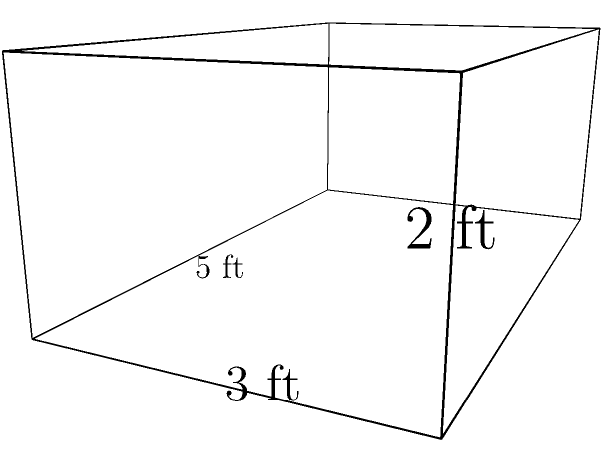A local library is organizing a book donation drive for your temperance movement organization. They've provided a rectangular storage box for the donated books. If the box measures 5 feet in length, 3 feet in width, and 2 feet in height, what is the volume of books that can be stored in this box? To find the volume of a rectangular prism (box), we need to multiply its length, width, and height.

Given:
- Length = 5 feet
- Width = 3 feet
- Height = 2 feet

Step 1: Apply the volume formula for a rectangular prism.
Volume = length × width × height

Step 2: Substitute the given values into the formula.
Volume = 5 ft × 3 ft × 2 ft

Step 3: Multiply the numbers.
Volume = 30 ft³

Therefore, the volume of books that can be stored in this box is 30 cubic feet.
Answer: 30 ft³ 